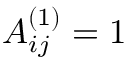Convert formula to latex. <formula><loc_0><loc_0><loc_500><loc_500>A _ { i j } ^ { ( 1 ) } = 1</formula> 